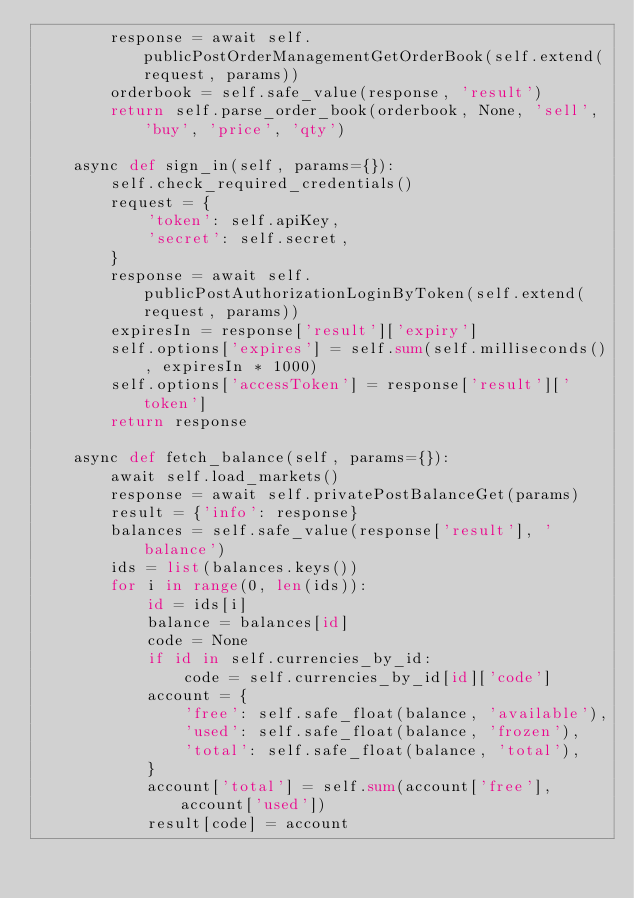<code> <loc_0><loc_0><loc_500><loc_500><_Python_>        response = await self.publicPostOrderManagementGetOrderBook(self.extend(request, params))
        orderbook = self.safe_value(response, 'result')
        return self.parse_order_book(orderbook, None, 'sell', 'buy', 'price', 'qty')

    async def sign_in(self, params={}):
        self.check_required_credentials()
        request = {
            'token': self.apiKey,
            'secret': self.secret,
        }
        response = await self.publicPostAuthorizationLoginByToken(self.extend(request, params))
        expiresIn = response['result']['expiry']
        self.options['expires'] = self.sum(self.milliseconds(), expiresIn * 1000)
        self.options['accessToken'] = response['result']['token']
        return response

    async def fetch_balance(self, params={}):
        await self.load_markets()
        response = await self.privatePostBalanceGet(params)
        result = {'info': response}
        balances = self.safe_value(response['result'], 'balance')
        ids = list(balances.keys())
        for i in range(0, len(ids)):
            id = ids[i]
            balance = balances[id]
            code = None
            if id in self.currencies_by_id:
                code = self.currencies_by_id[id]['code']
            account = {
                'free': self.safe_float(balance, 'available'),
                'used': self.safe_float(balance, 'frozen'),
                'total': self.safe_float(balance, 'total'),
            }
            account['total'] = self.sum(account['free'], account['used'])
            result[code] = account</code> 